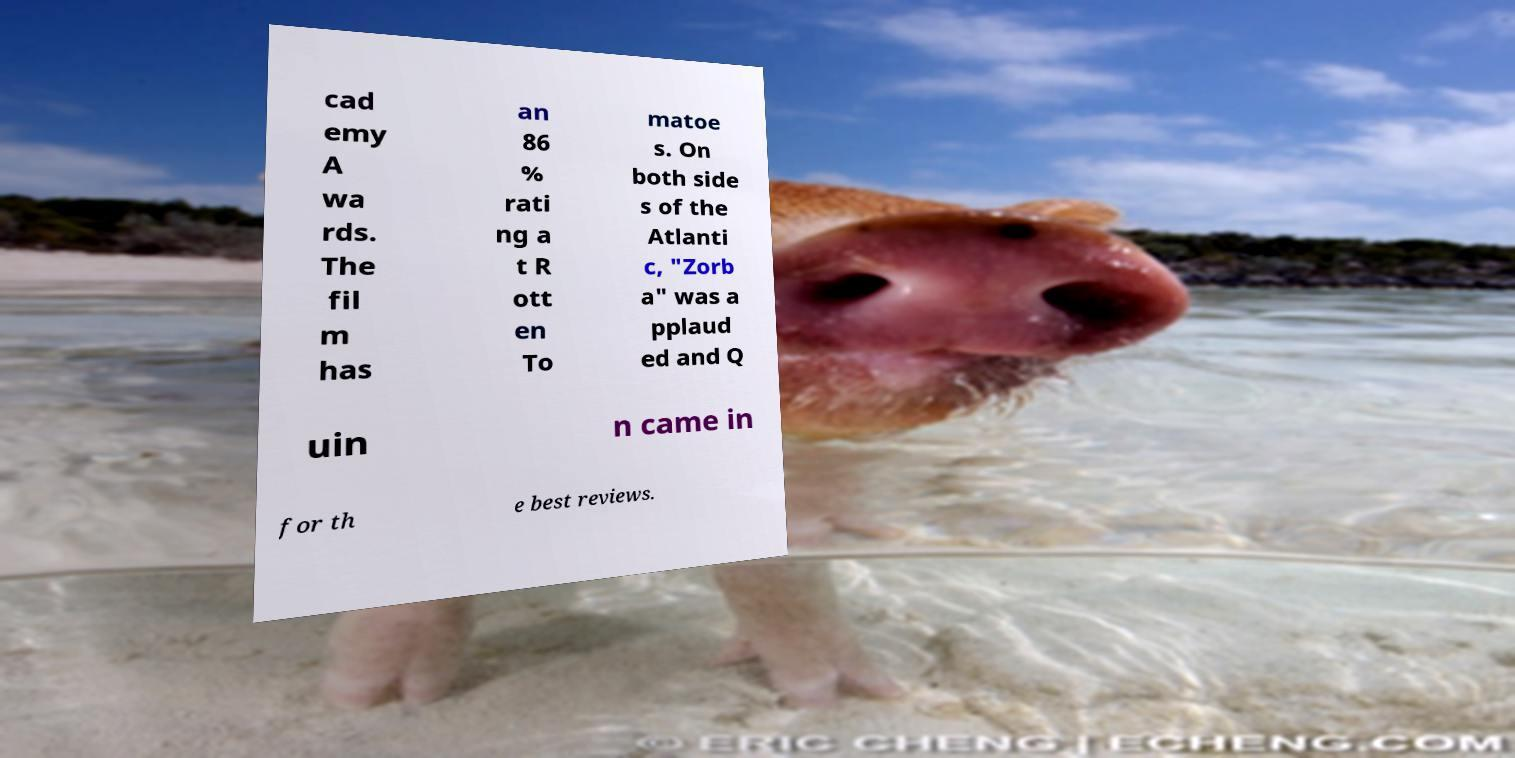For documentation purposes, I need the text within this image transcribed. Could you provide that? cad emy A wa rds. The fil m has an 86 % rati ng a t R ott en To matoe s. On both side s of the Atlanti c, "Zorb a" was a pplaud ed and Q uin n came in for th e best reviews. 